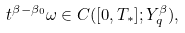Convert formula to latex. <formula><loc_0><loc_0><loc_500><loc_500>t ^ { \beta - \beta _ { 0 } } \omega \in C ( [ 0 , T _ { * } ] ; Y ^ { \beta } _ { q } ) ,</formula> 